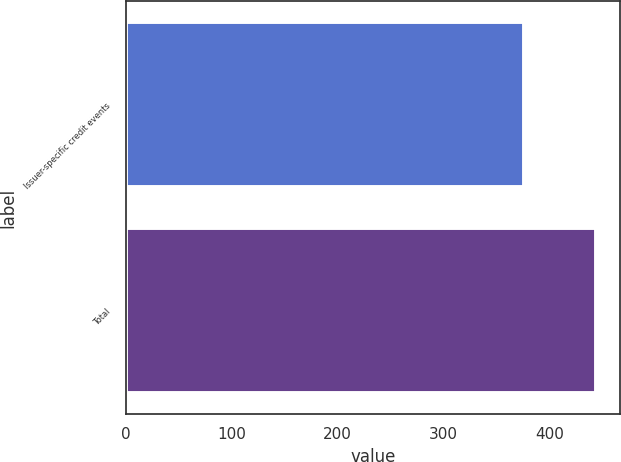Convert chart. <chart><loc_0><loc_0><loc_500><loc_500><bar_chart><fcel>Issuer-specific credit events<fcel>Total<nl><fcel>376<fcel>444<nl></chart> 